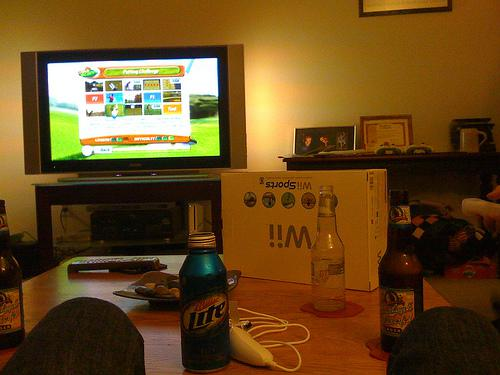Question: what is in the hand on the right side of the picture?
Choices:
A. NES Controller.
B. XBox Controller.
C. Playstation Controller.
D. WII controller.
Answer with the letter. Answer: D Question: where is the cup?
Choices:
A. Counter.
B. Table.
C. Sink.
D. Shelf.
Answer with the letter. Answer: D Question: where was the photo taken?
Choices:
A. Outdoors.
B. Sauna.
C. Hallway.
D. Living room.
Answer with the letter. Answer: D 